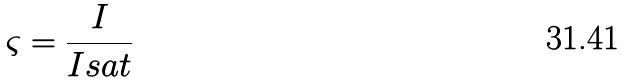Convert formula to latex. <formula><loc_0><loc_0><loc_500><loc_500>\varsigma = \frac { I } { I s a t }</formula> 